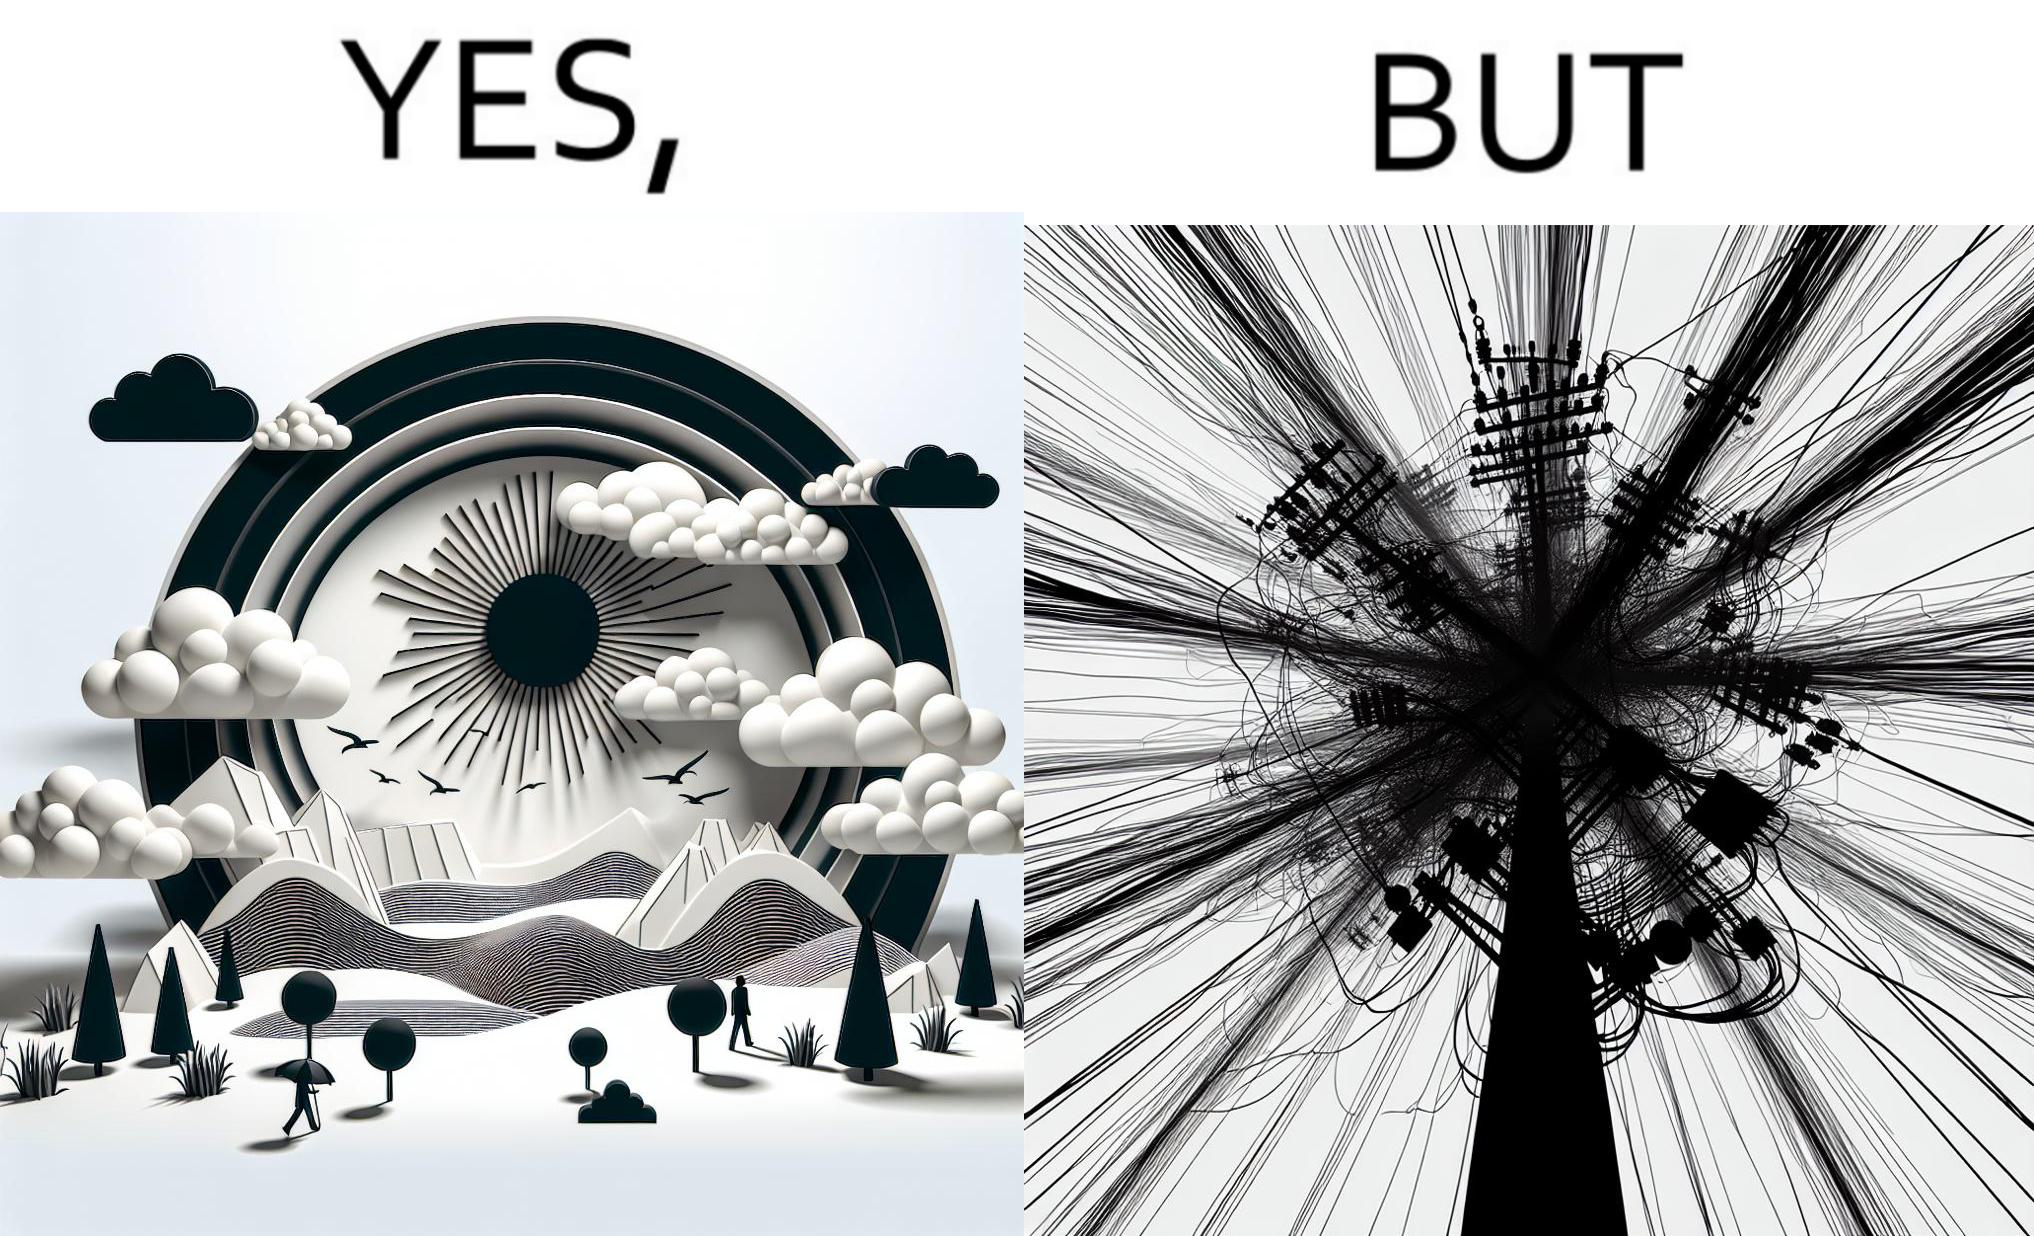Is there satirical content in this image? Yes, this image is satirical. 